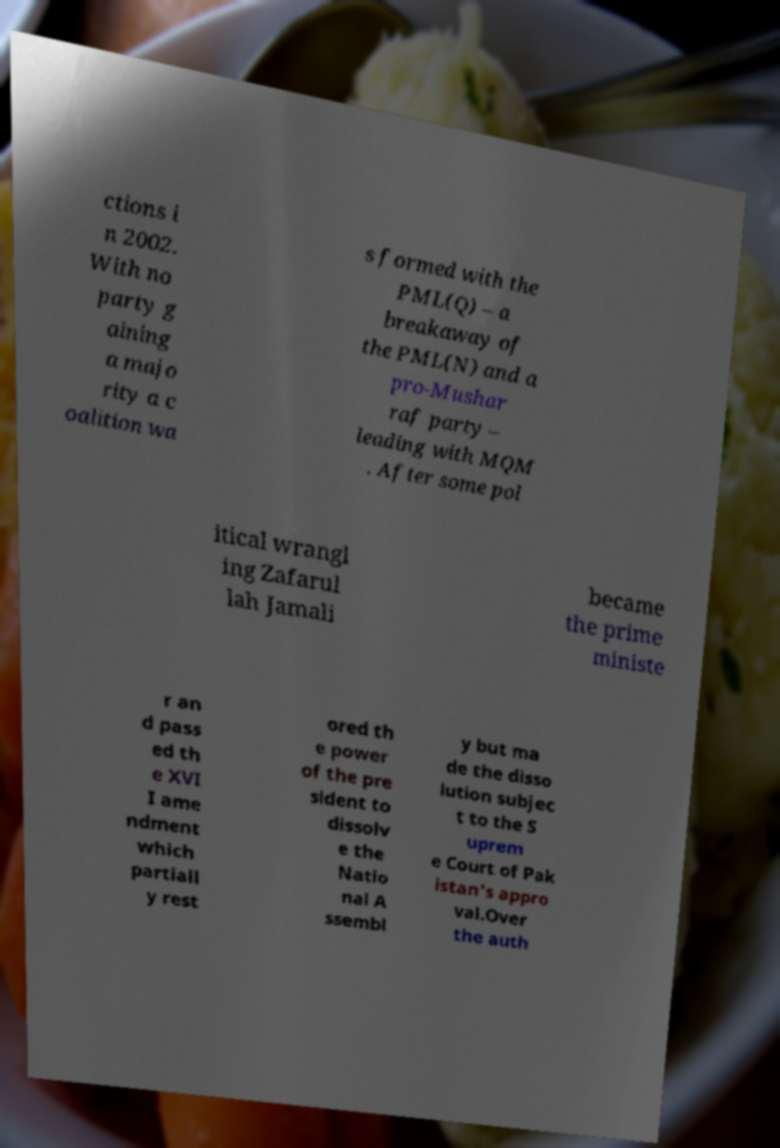Please read and relay the text visible in this image. What does it say? ctions i n 2002. With no party g aining a majo rity a c oalition wa s formed with the PML(Q) – a breakaway of the PML(N) and a pro-Mushar raf party – leading with MQM . After some pol itical wrangl ing Zafarul lah Jamali became the prime ministe r an d pass ed th e XVI I ame ndment which partiall y rest ored th e power of the pre sident to dissolv e the Natio nal A ssembl y but ma de the disso lution subjec t to the S uprem e Court of Pak istan's appro val.Over the auth 